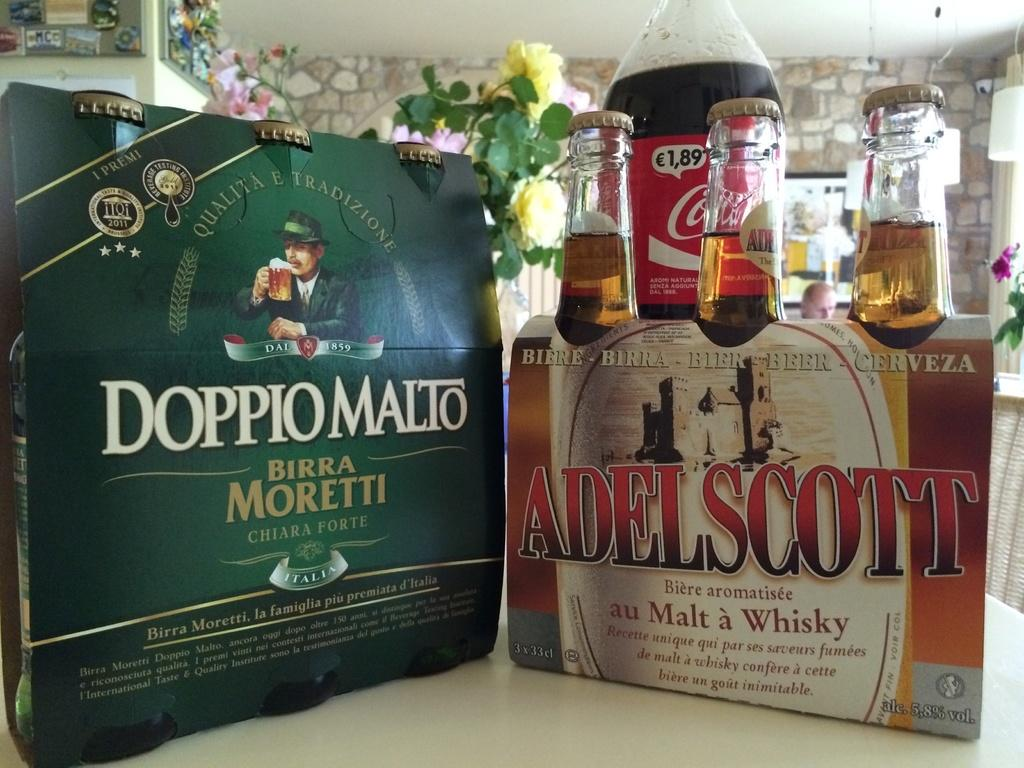<image>
Present a compact description of the photo's key features. six pack beer of Birra Moretti and Adel Scott 